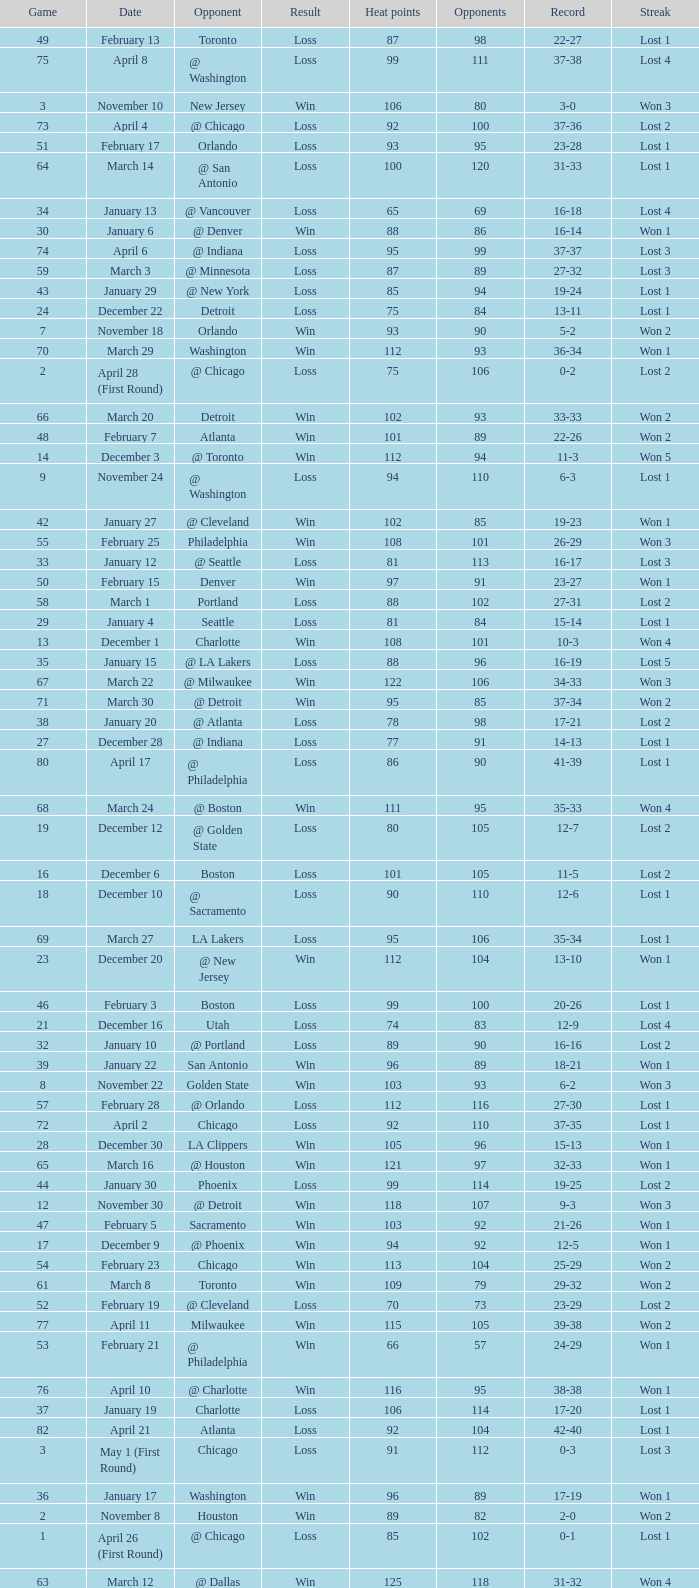What is the highest Game, when Opponents is less than 80, and when Record is "1-0"? 1.0. 